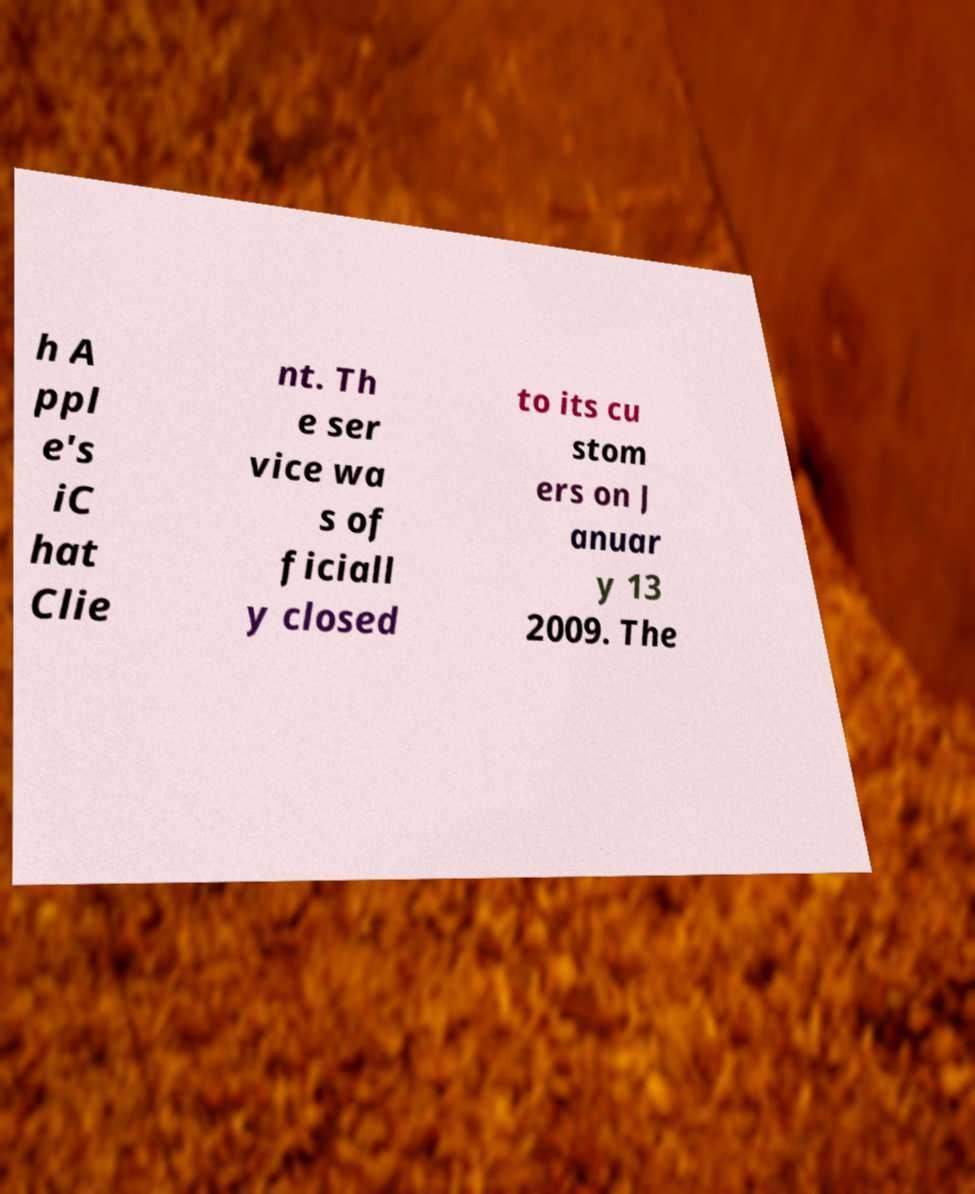I need the written content from this picture converted into text. Can you do that? h A ppl e's iC hat Clie nt. Th e ser vice wa s of ficiall y closed to its cu stom ers on J anuar y 13 2009. The 